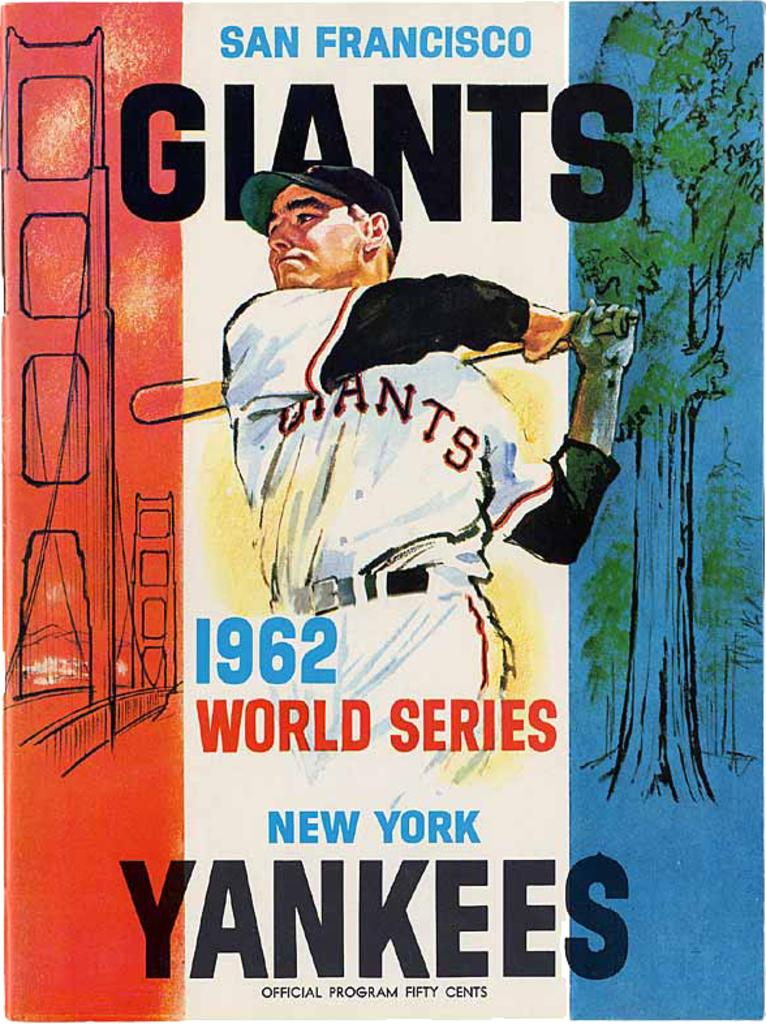<image>
Write a terse but informative summary of the picture. A poster for the 1962 World Series where the San Francisco Giants versed the New York Yankees 